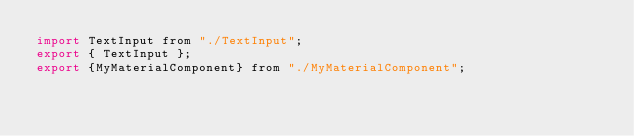Convert code to text. <code><loc_0><loc_0><loc_500><loc_500><_JavaScript_>import TextInput from "./TextInput";
export { TextInput };
export {MyMaterialComponent} from "./MyMaterialComponent";</code> 